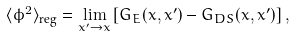Convert formula to latex. <formula><loc_0><loc_0><loc_500><loc_500>\langle \phi ^ { 2 } \rangle _ { \text {reg} } = \lim _ { x ^ { \prime } \to x } \left [ G _ { E } ( x , x ^ { \prime } ) - G _ { D S } ( x , x ^ { \prime } ) \right ] ,</formula> 